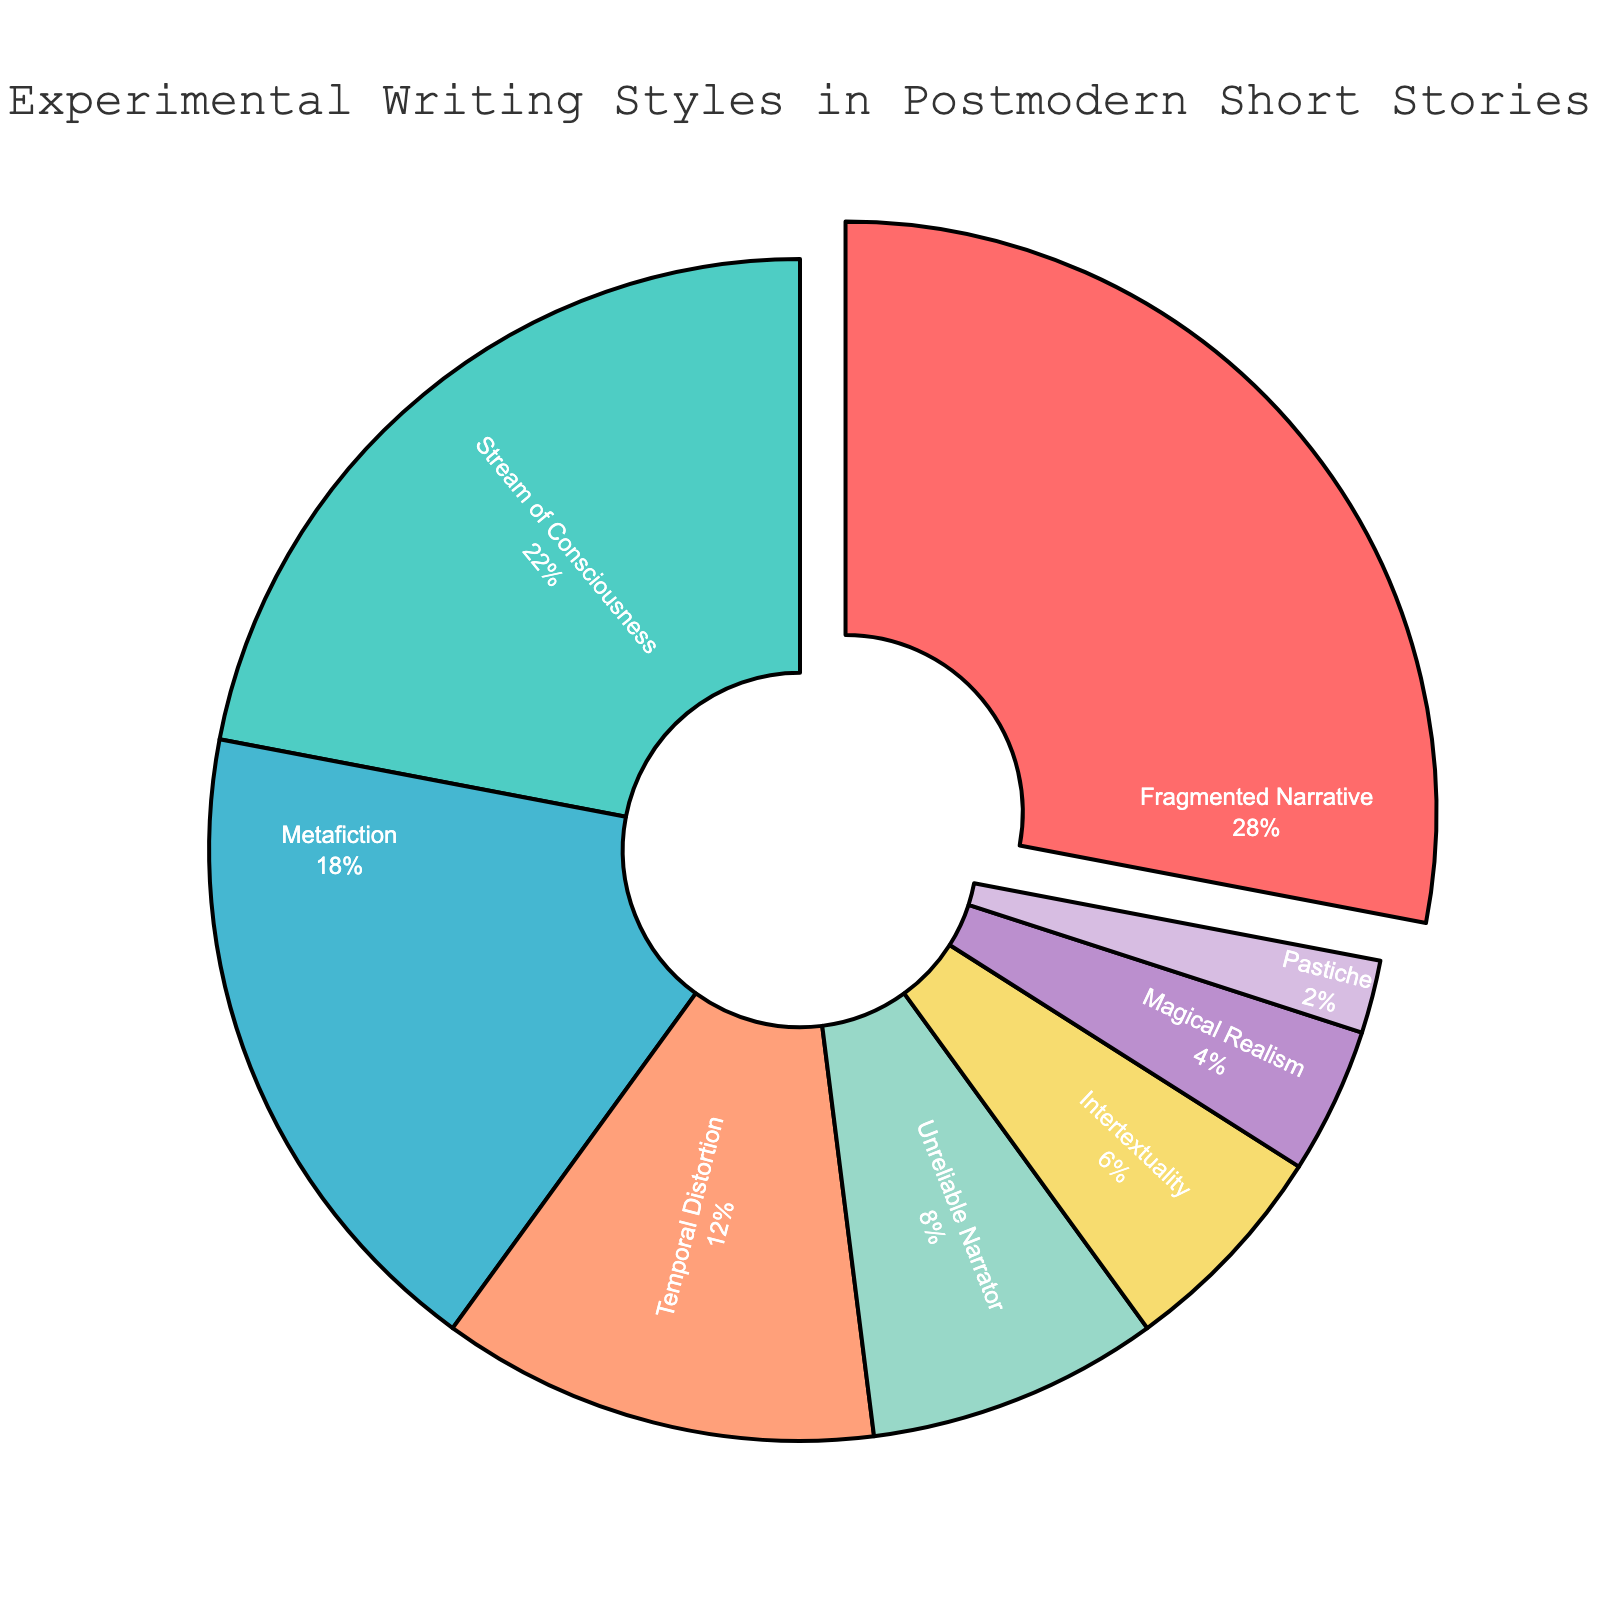What's the most common experimental writing style in postmodern short stories? The pie chart shows the largest segment highlighting the writing style with the highest percentage, which is the Fragmented Narrative with 28%.
Answer: Fragmented Narrative Which writing style is the least common in the dataset? The smallest segment in the pie chart represents the least common writing style. Pastiche occupies the smallest fraction with only 2%.
Answer: Pastiche How much more prevalent is Stream of Consciousness compared to Magical Realism? Stream of Consciousness is 22% while Magical Realism is 4%. The difference is \(22 - 4 = 18\%\).
Answer: 18% What percentage of the stories use either the Fragmented Narrative or Metafiction? The Fragmented Narrative is 28% and Metafiction is 18%. Their combined percentage is \(28 + 18 = 46\%\).
Answer: 46% Compare the combined percentage of Temporal Distortion and Unreliable Narrator styles to Stream of Consciousness. Which is higher? Temporal Distortion and Unreliable Narrator are 12% and 8% respectively. Their total is \(12 + 8 = 20\%\). Stream of Consciousness alone is 22%. Stream of Consciousness is higher.
Answer: Stream of Consciousness What writing styles have a combined percentage of 50%? Adding the styles in descending order: Fragmented Narrative (28%) + Stream of Consciousness (22%) = 50%.
Answer: Fragmented Narrative and Stream of Consciousness Which writing style is represented by the green slice in the pie chart? The slice colored in green represents Stream of Consciousness.
Answer: Stream of Consciousness Is the percentage of Intertextuality higher or lower than the combined percentage of Magical Realism and Pastiche? Intertextuality is 6%. Magical Realism and Pastiche together are \(4 + 2 = 6\%\). They are equal.
Answer: Equal Which writing style is visually pulled out from the pie chart and why? The Fragmented Narrative segment is visually pulled out. This is because it has the highest percentage (28%).
Answer: Fragmented Narrative What is the percentage difference between Metafiction and Intertextuality? Metafiction is 18% and Intertextuality is 6%. The difference is \(18 - 6 = 12\%\).
Answer: 12% 